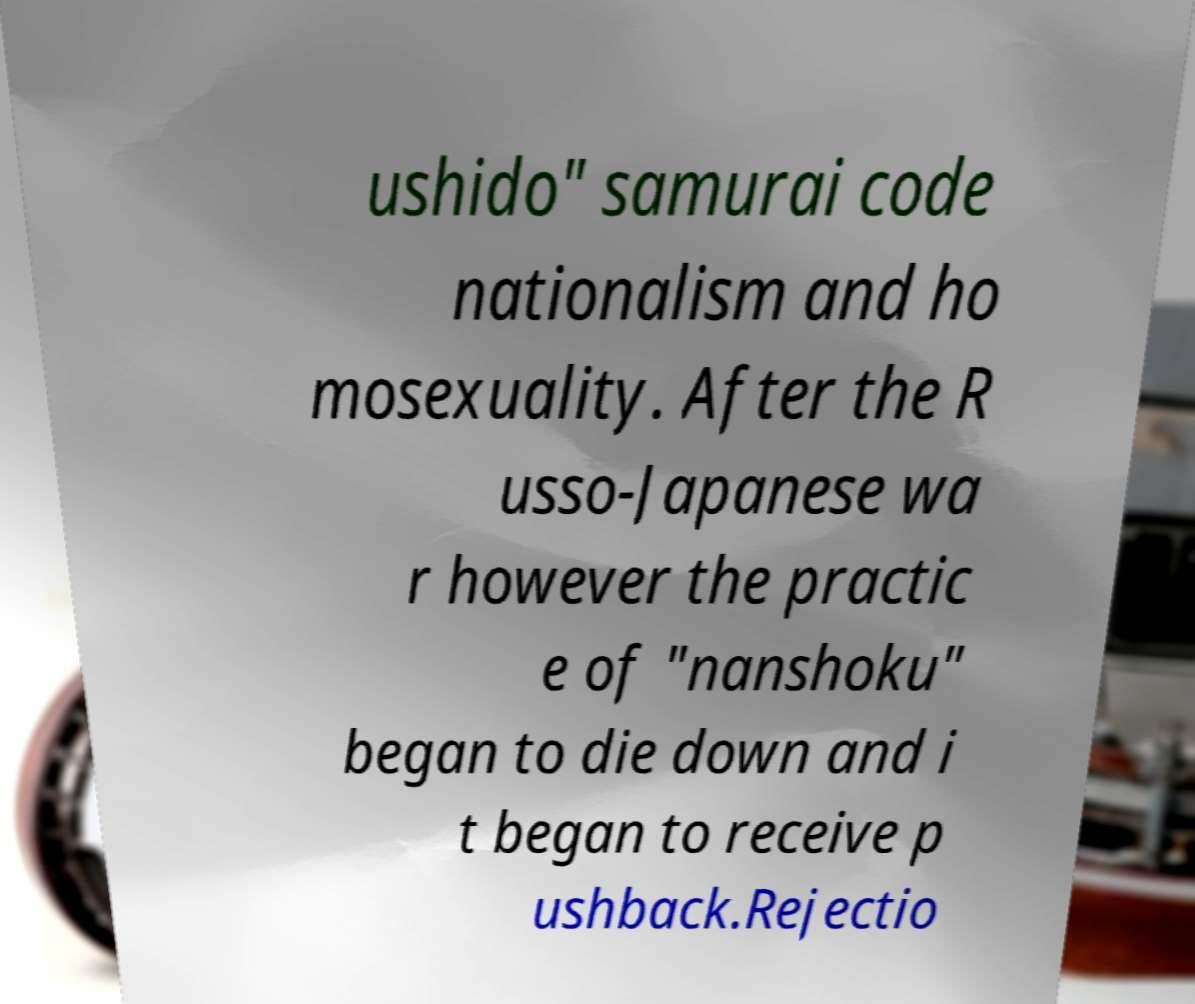There's text embedded in this image that I need extracted. Can you transcribe it verbatim? ushido" samurai code nationalism and ho mosexuality. After the R usso-Japanese wa r however the practic e of "nanshoku" began to die down and i t began to receive p ushback.Rejectio 